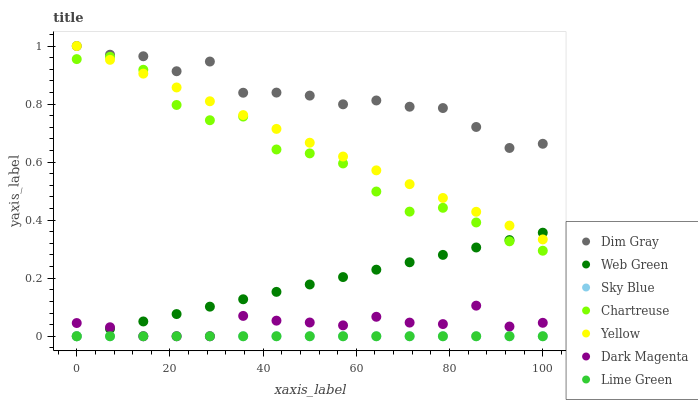Does Sky Blue have the minimum area under the curve?
Answer yes or no. Yes. Does Dim Gray have the maximum area under the curve?
Answer yes or no. Yes. Does Dark Magenta have the minimum area under the curve?
Answer yes or no. No. Does Dark Magenta have the maximum area under the curve?
Answer yes or no. No. Is Sky Blue the smoothest?
Answer yes or no. Yes. Is Chartreuse the roughest?
Answer yes or no. Yes. Is Dark Magenta the smoothest?
Answer yes or no. No. Is Dark Magenta the roughest?
Answer yes or no. No. Does Dark Magenta have the lowest value?
Answer yes or no. Yes. Does Yellow have the lowest value?
Answer yes or no. No. Does Yellow have the highest value?
Answer yes or no. Yes. Does Dark Magenta have the highest value?
Answer yes or no. No. Is Dark Magenta less than Dim Gray?
Answer yes or no. Yes. Is Yellow greater than Dark Magenta?
Answer yes or no. Yes. Does Yellow intersect Chartreuse?
Answer yes or no. Yes. Is Yellow less than Chartreuse?
Answer yes or no. No. Is Yellow greater than Chartreuse?
Answer yes or no. No. Does Dark Magenta intersect Dim Gray?
Answer yes or no. No. 